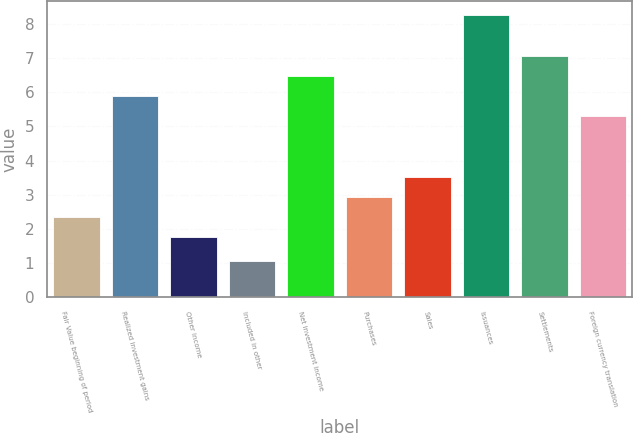<chart> <loc_0><loc_0><loc_500><loc_500><bar_chart><fcel>Fair Value beginning of period<fcel>Realized investment gains<fcel>Other income<fcel>Included in other<fcel>Net investment income<fcel>Purchases<fcel>Sales<fcel>Issuances<fcel>Settlements<fcel>Foreign currency translation<nl><fcel>2.35<fcel>5.89<fcel>1.76<fcel>1.07<fcel>6.48<fcel>2.94<fcel>3.53<fcel>8.25<fcel>7.07<fcel>5.3<nl></chart> 